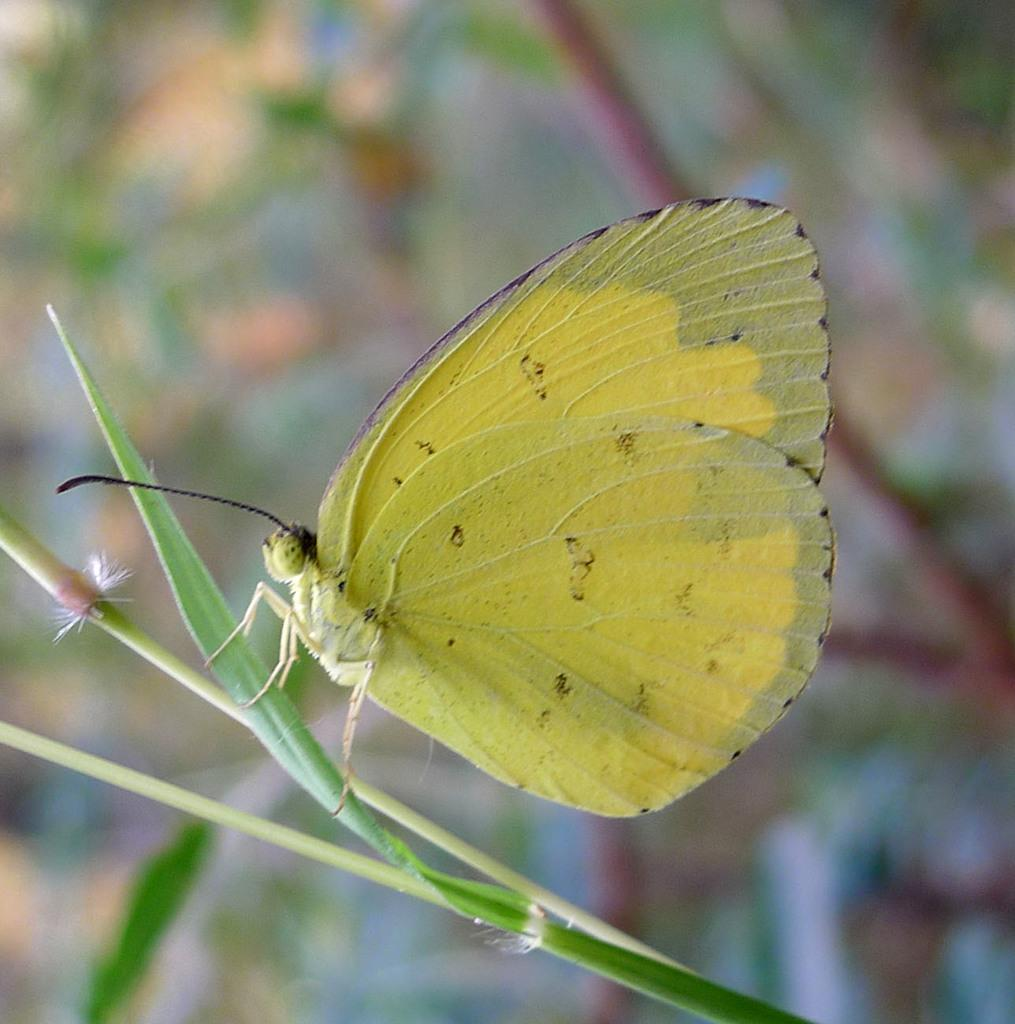What type of animal can be seen in the image? There is a butterfly in the image. What else is present in the image besides the butterfly? There is a leaf in the image. Can you describe the background of the image? The background of the image is blurry. What type of regret can be seen on the breakfast table in the image? There is no breakfast table or regret present in the image; it features a butterfly and a leaf with a blurry background. 